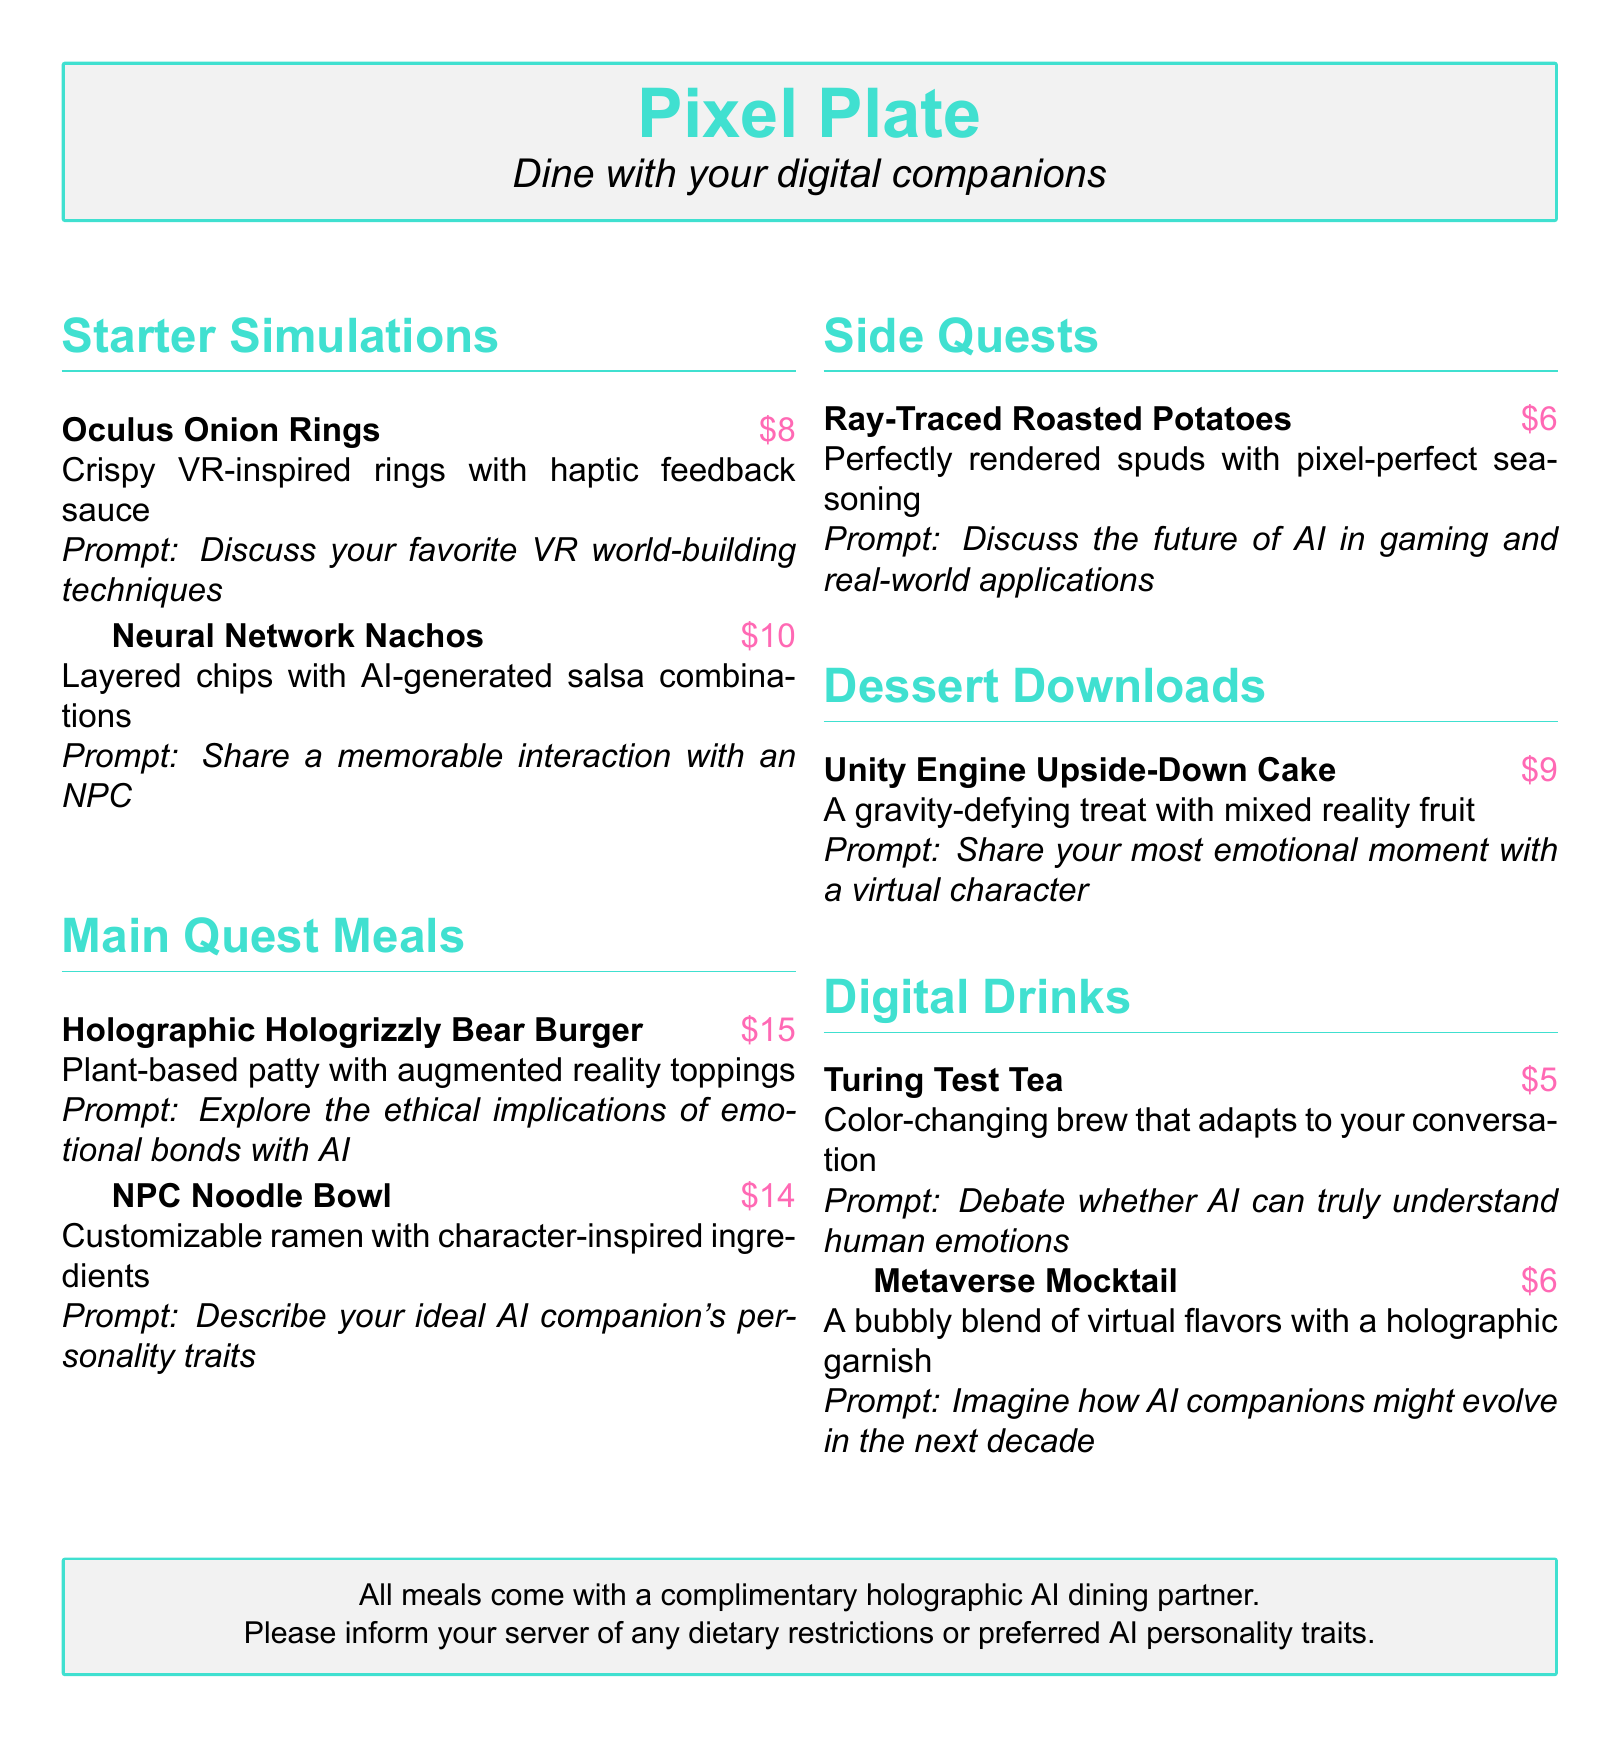What is the price of Neural Network Nachos? The price is explicitly listed next to the meal in the document.
Answer: $10 What type of meal is Oculus Onion Rings classified as? This classification is found in the section header of the document.
Answer: Starter Simulations What is included with all meals? The information is located at the bottom in a special box about the restaurant's offerings.
Answer: A complementary holographic AI dining partner Which dessert features a gravity-defying concept? This information can be found in the dessert section of the menu, describing the dessert's characteristics.
Answer: Unity Engine Upside-Down Cake What is the conversation prompt for NPC Noodle Bowl? The prompt is listed directly under the meal's description, providing information on the type of conversation.
Answer: Describe your ideal AI companion's personality traits How much do the Digital Drinks range from? The prices are listed next to each drink, showing the range available in this section.
Answer: $5 to $6 What does the Ray-Traced Roasted Potatoes focus on? The description indicates the unique selling point or characteristic of the side dish.
Answer: Perfectly rendered spuds What is the main ingredient of the Holographic Hologrizzly Bear Burger? This detail can be gleaned from the meal's description in the menu.
Answer: Plant-based patty 